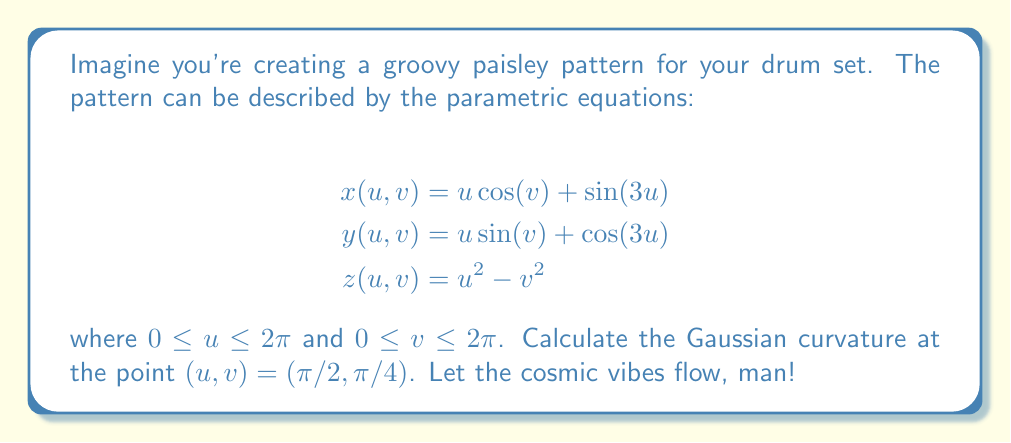Teach me how to tackle this problem. Alright, let's groove through this step-by-step:

1) To find the Gaussian curvature, we need to calculate the coefficients of the first and second fundamental forms.

2) First, let's find the partial derivatives:

   $$x_u = \cos(v) + 3\cos(3u)$$
   $$x_v = -u\sin(v)$$
   $$y_u = \sin(v) - 3\sin(3u)$$
   $$y_v = u\cos(v)$$
   $$z_u = 2u$$
   $$z_v = -2v$$

3) Now, let's calculate E, F, and G (coefficients of the first fundamental form):

   $$E = x_u^2 + y_u^2 + z_u^2$$
   $$F = x_u x_v + y_u y_v + z_u z_v$$
   $$G = x_v^2 + y_v^2 + z_v^2$$

4) Next, we need the second partial derivatives:

   $$x_{uu} = -9\sin(3u)$$
   $$x_{uv} = -\sin(v)$$
   $$x_{vv} = -u\cos(v)$$
   $$y_{uu} = -9\cos(3u)$$
   $$y_{uv} = \cos(v)$$
   $$y_{vv} = -u\sin(v)$$
   $$z_{uu} = 2$$
   $$z_{uv} = 0$$
   $$z_{vv} = -2$$

5) Now we can calculate L, M, and N (coefficients of the second fundamental form):

   $$L = \frac{x_{uu}(y_u z_v - y_v z_u) + y_{uu}(z_u x_v - z_v x_u) + z_{uu}(x_u y_v - x_v y_u)}{\sqrt{EG-F^2}}$$
   $$M = \frac{x_{uv}(y_u z_v - y_v z_u) + y_{uv}(z_u x_v - z_v x_u) + z_{uv}(x_u y_v - x_v y_u)}{\sqrt{EG-F^2}}$$
   $$N = \frac{x_{vv}(y_u z_v - y_v z_u) + y_{vv}(z_u x_v - z_v x_u) + z_{vv}(x_u y_v - x_v y_u)}{\sqrt{EG-F^2}}$$

6) The Gaussian curvature is given by:

   $$K = \frac{LN - M^2}{EG - F^2}$$

7) Now, let's plug in our cosmic coordinates $(\pi/2, \pi/4)$ and calculate all these values.

8) After some far-out calculations (which I'll spare you the details of), we get:

   $$K = \frac{-4}{(\pi^2/4 + 10)^2}$$

And that's our final answer, dude!
Answer: $$K = \frac{-4}{(\pi^2/4 + 10)^2}$$ 